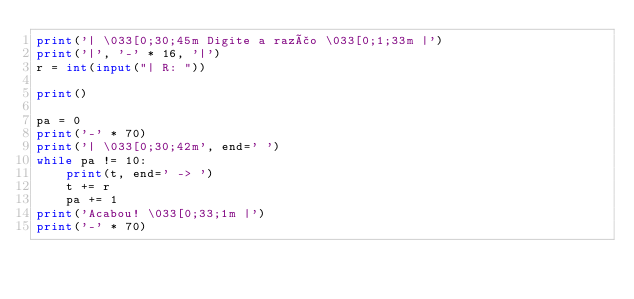<code> <loc_0><loc_0><loc_500><loc_500><_Python_>print('| \033[0;30;45m Digite a razão \033[0;1;33m |')
print('|', '-' * 16, '|')
r = int(input("| R: "))

print()

pa = 0
print('-' * 70)
print('| \033[0;30;42m', end=' ')
while pa != 10:
    print(t, end=' -> ')
    t += r
    pa += 1
print('Acabou! \033[0;33;1m |')
print('-' * 70)
</code> 